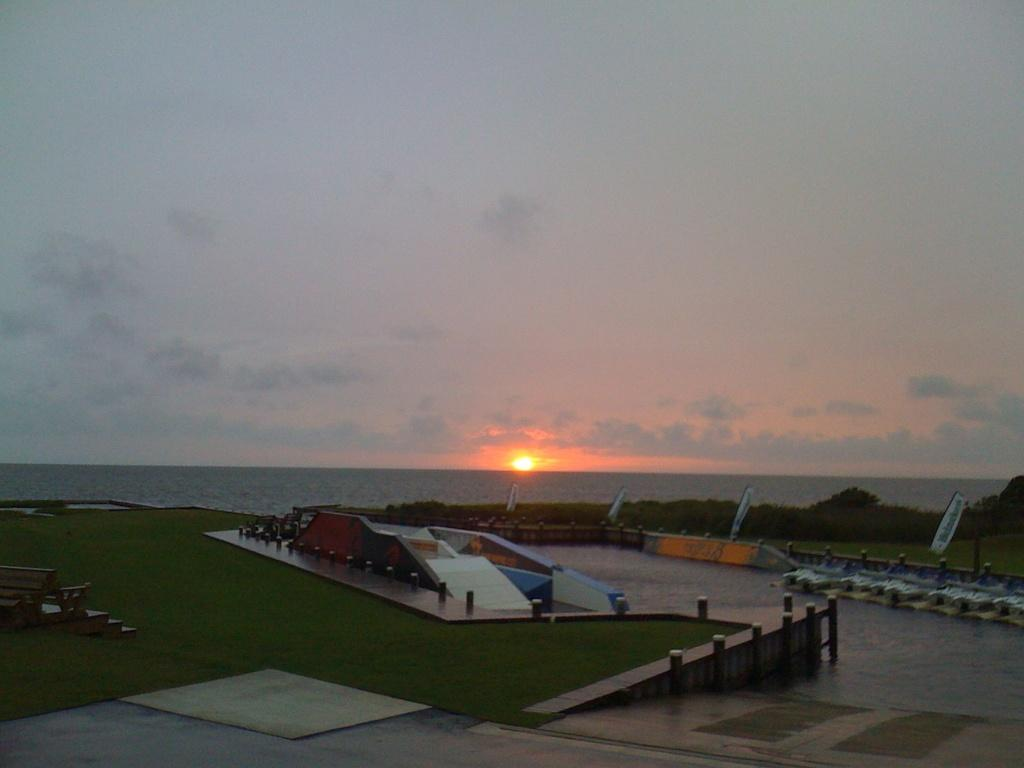What type of vegetation is present in the image? There is grass in the image. What can be seen on the ground in the image? There are objects on the ground in the image. What is visible in the background of the image? Trees, water, and the sky are visible in the background of the image. What is the income of the person holding the cup in the image? There is no person holding a cup in the image, nor is there any information about income provided. 